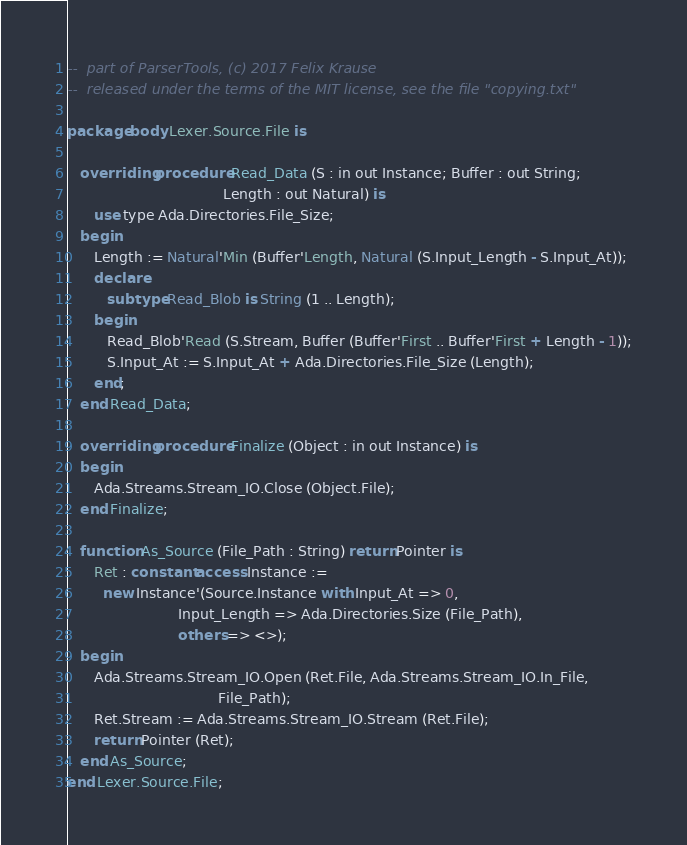Convert code to text. <code><loc_0><loc_0><loc_500><loc_500><_Ada_>--  part of ParserTools, (c) 2017 Felix Krause
--  released under the terms of the MIT license, see the file "copying.txt"

package body Lexer.Source.File is

   overriding procedure Read_Data (S : in out Instance; Buffer : out String;
                                   Length : out Natural) is
      use type Ada.Directories.File_Size;
   begin
      Length := Natural'Min (Buffer'Length, Natural (S.Input_Length - S.Input_At));
      declare
         subtype Read_Blob is String (1 .. Length);
      begin
         Read_Blob'Read (S.Stream, Buffer (Buffer'First .. Buffer'First + Length - 1));
         S.Input_At := S.Input_At + Ada.Directories.File_Size (Length);
      end;
   end Read_Data;

   overriding procedure Finalize (Object : in out Instance) is
   begin
      Ada.Streams.Stream_IO.Close (Object.File);
   end Finalize;

   function As_Source (File_Path : String) return Pointer is
      Ret : constant access Instance :=
        new Instance'(Source.Instance with Input_At => 0,
                         Input_Length => Ada.Directories.Size (File_Path),
                         others => <>);
   begin
      Ada.Streams.Stream_IO.Open (Ret.File, Ada.Streams.Stream_IO.In_File,
                                  File_Path);
      Ret.Stream := Ada.Streams.Stream_IO.Stream (Ret.File);
      return Pointer (Ret);
   end As_Source;
end Lexer.Source.File;
</code> 